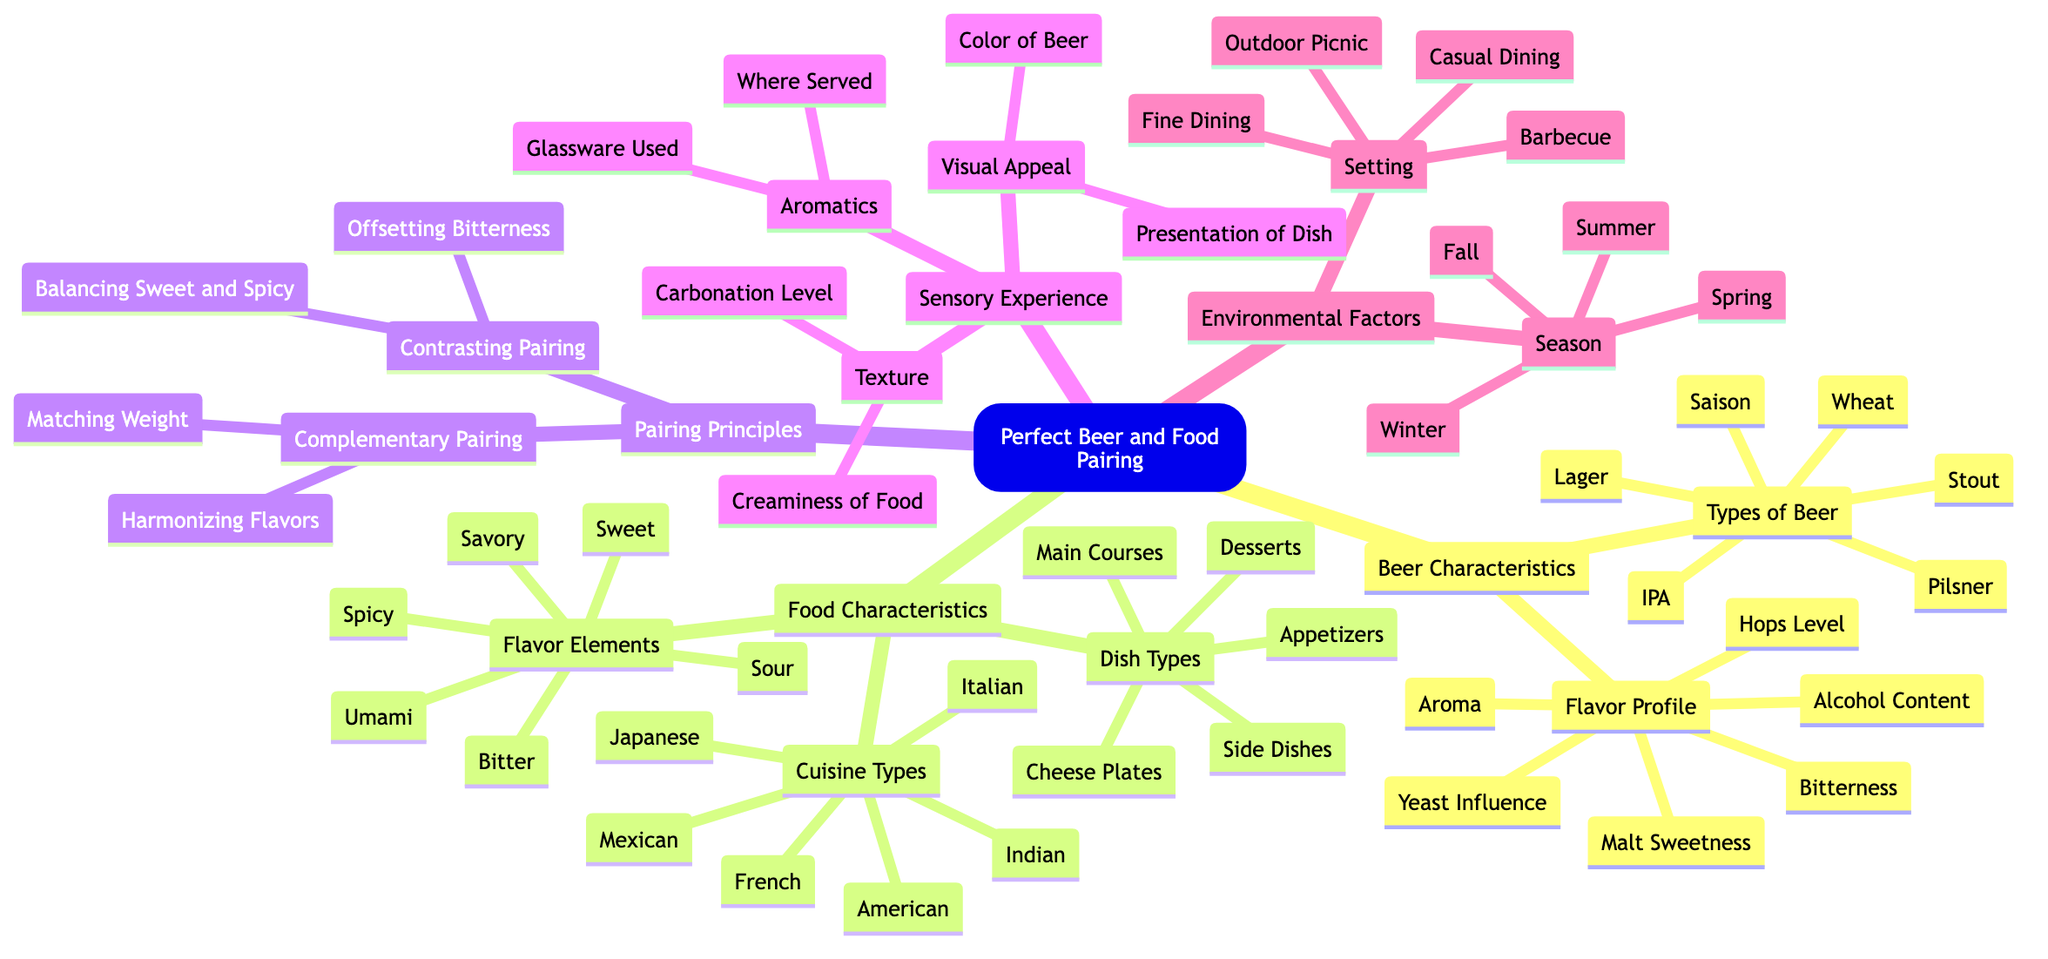What are the two main types of beer mentioned? The diagram lists "Types of Beer" under "Beer Characteristics." The two main types identified are found in this category, specifically "IPA" and "Stout."
Answer: IPA, Stout How many flavors are found under Food Characteristics? "Flavor Elements" is a subcategory under "Food Characteristics." There are six flavors listed: Spicy, Sweet, Savory, Sour, Bitter, and Umami, making it a total of six flavors.
Answer: 6 What is meant by complementary pairing? "Complementary Pairing" falls under "Pairing Principles." It includes "Matching Weight" and "Harmonizing Flavors," indicating methods to create a balanced beer and food pairing.
Answer: Matching Weight, Harmonizing Flavors Name one of the sensory experience factors. The diagram presents "Sensory Experience" as a category. Under this, "Visual Appeal," "Aromatics," and "Texture" are listed as factors, so one example of a sensory experience factor is "Visual Appeal."
Answer: Visual Appeal Which season is associated with outdoor picnics? The "Environmental Factors" section includes "Season" and "Setting." "Outdoor Picnic" is linked to "Summer," indicating that this season is favorable for picnics.
Answer: Summer How does balancing sweet and spicy relate to pairing principles? "Balancing Sweet and Spicy" is categorized under "Contrasting Pairing" within "Pairing Principles," showcasing how contrasting flavors can enhance the overall pairing experience.
Answer: Contrasting Pairing What kind of dish types can be paired with beer? The diagram identifies "Dish Types" under "Food Characteristics," which includes "Main Courses," "Appetizers," "Desserts," "Cheese Plates," and "Side Dishes," indicating various dishes that can be paired.
Answer: Appetizers, Main Courses, Desserts, Cheese Plates, Side Dishes How many types of cuisine are listed? Under "Food Characteristics," the "Cuisine Types" section details six options: Italian, Mexican, French, Japanese, American, and Indian, making a total of six cuisine types.
Answer: 6 What visual aspect is mentioned that influences beer and food pairing? "Color of Beer" is a component in the "Visual Appeal" category, representing one critical visual aspect that affects the pairing experience.
Answer: Color of Beer 